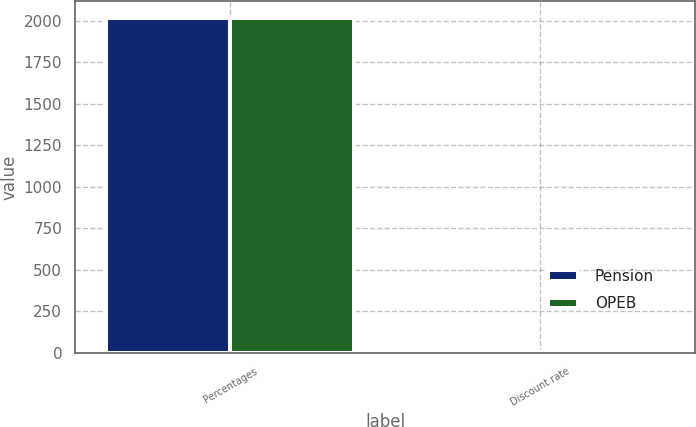Convert chart. <chart><loc_0><loc_0><loc_500><loc_500><stacked_bar_chart><ecel><fcel>Percentages<fcel>Discount rate<nl><fcel>Pension<fcel>2016<fcel>4.2<nl><fcel>OPEB<fcel>2016<fcel>4<nl></chart> 